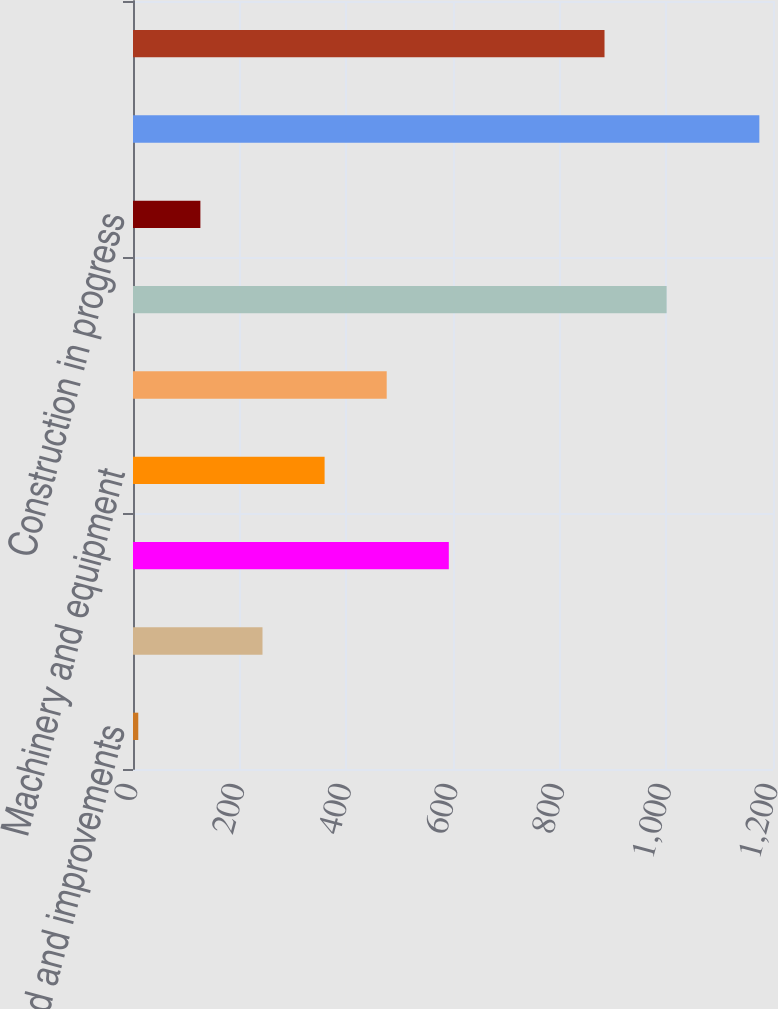Convert chart. <chart><loc_0><loc_0><loc_500><loc_500><bar_chart><fcel>Land and improvements<fcel>Buildings and improvements<fcel>Furniture and fixtures<fcel>Machinery and equipment<fcel>Capitalized software<fcel>Leasehold improvements<fcel>Construction in progress<fcel>Less accumulated depreciation<fcel>Property and equipment net<nl><fcel>9.9<fcel>242.8<fcel>592.15<fcel>359.25<fcel>475.7<fcel>1000.55<fcel>126.35<fcel>1174.4<fcel>884.1<nl></chart> 